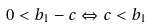<formula> <loc_0><loc_0><loc_500><loc_500>0 < b _ { 1 } - c \Leftrightarrow c < b _ { 1 }</formula> 